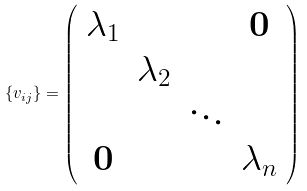Convert formula to latex. <formula><loc_0><loc_0><loc_500><loc_500>\{ v _ { i j } \} = \left ( \begin{array} { c c c c } \lambda _ { 1 } & & & \mathbf 0 \\ & \lambda _ { 2 } & & \\ & & \ddots & \\ \mathbf 0 & & & \lambda _ { n } \end{array} \right )</formula> 